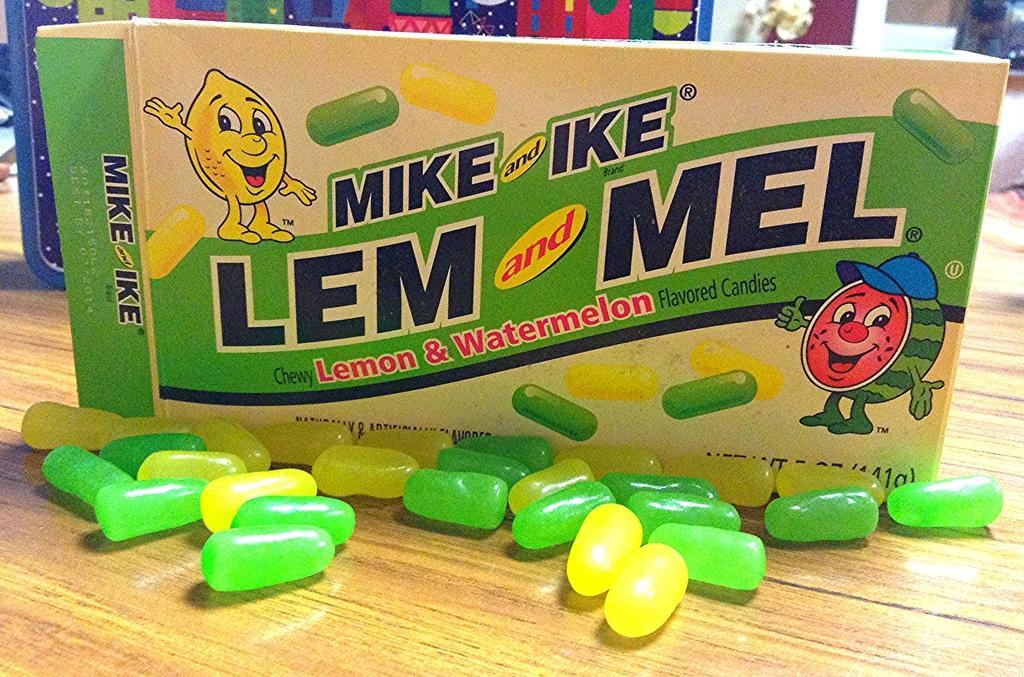How would you summarize this image in a sentence or two? In this image we can see the flavored candies pack. We can also see the candies on the wooden surface. In the background, we can see some objects. 